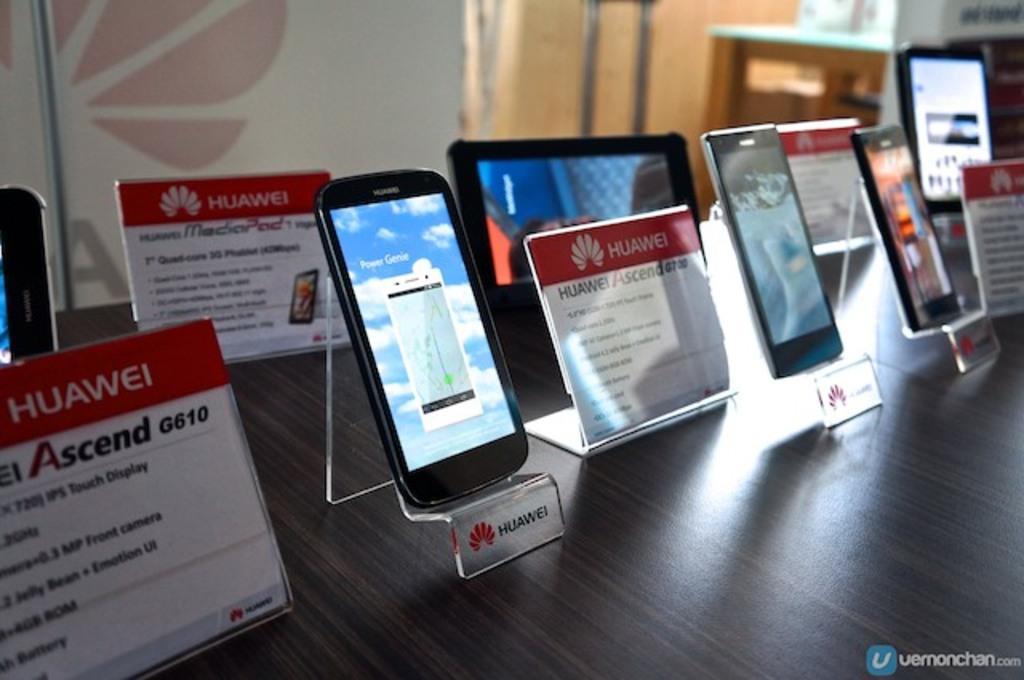<image>
Share a concise interpretation of the image provided. A smart phone is on a clear stand that says Huawei on it. 